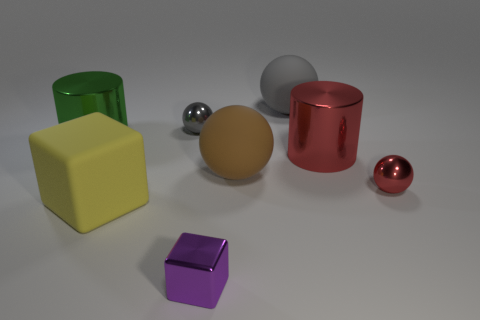Subtract all gray rubber balls. How many balls are left? 3 Add 1 gray matte things. How many objects exist? 9 Subtract all brown spheres. How many spheres are left? 3 Subtract 3 spheres. How many spheres are left? 1 Subtract all purple cubes. Subtract all gray balls. How many cubes are left? 1 Subtract all green spheres. How many blue cylinders are left? 0 Subtract all tiny cylinders. Subtract all large green cylinders. How many objects are left? 7 Add 3 large things. How many large things are left? 8 Add 8 small blocks. How many small blocks exist? 9 Subtract 0 red cubes. How many objects are left? 8 